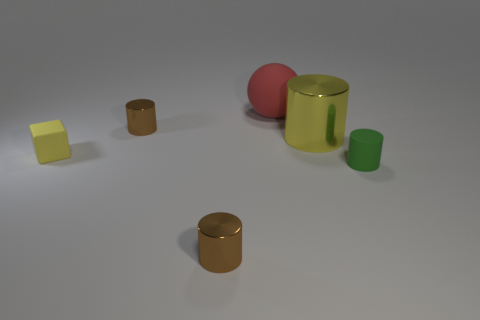The thing in front of the small green cylinder has what shape?
Offer a terse response. Cylinder. What is the color of the small metal thing that is behind the tiny brown metal thing that is in front of the small yellow object?
Your answer should be compact. Brown. How many objects are tiny rubber objects that are on the right side of the yellow metallic cylinder or rubber cylinders?
Provide a short and direct response. 1. There is a yellow metallic thing; is its size the same as the brown metal thing in front of the big metallic thing?
Make the answer very short. No. How many big objects are yellow things or red matte objects?
Give a very brief answer. 2. What is the shape of the big yellow metal thing?
Your answer should be compact. Cylinder. What is the size of the shiny object that is the same color as the matte block?
Ensure brevity in your answer.  Large. Is there a big yellow object made of the same material as the large sphere?
Provide a short and direct response. No. Is the number of matte cylinders greater than the number of blue rubber cylinders?
Your answer should be very brief. Yes. Are the small yellow block and the yellow cylinder made of the same material?
Offer a terse response. No. 